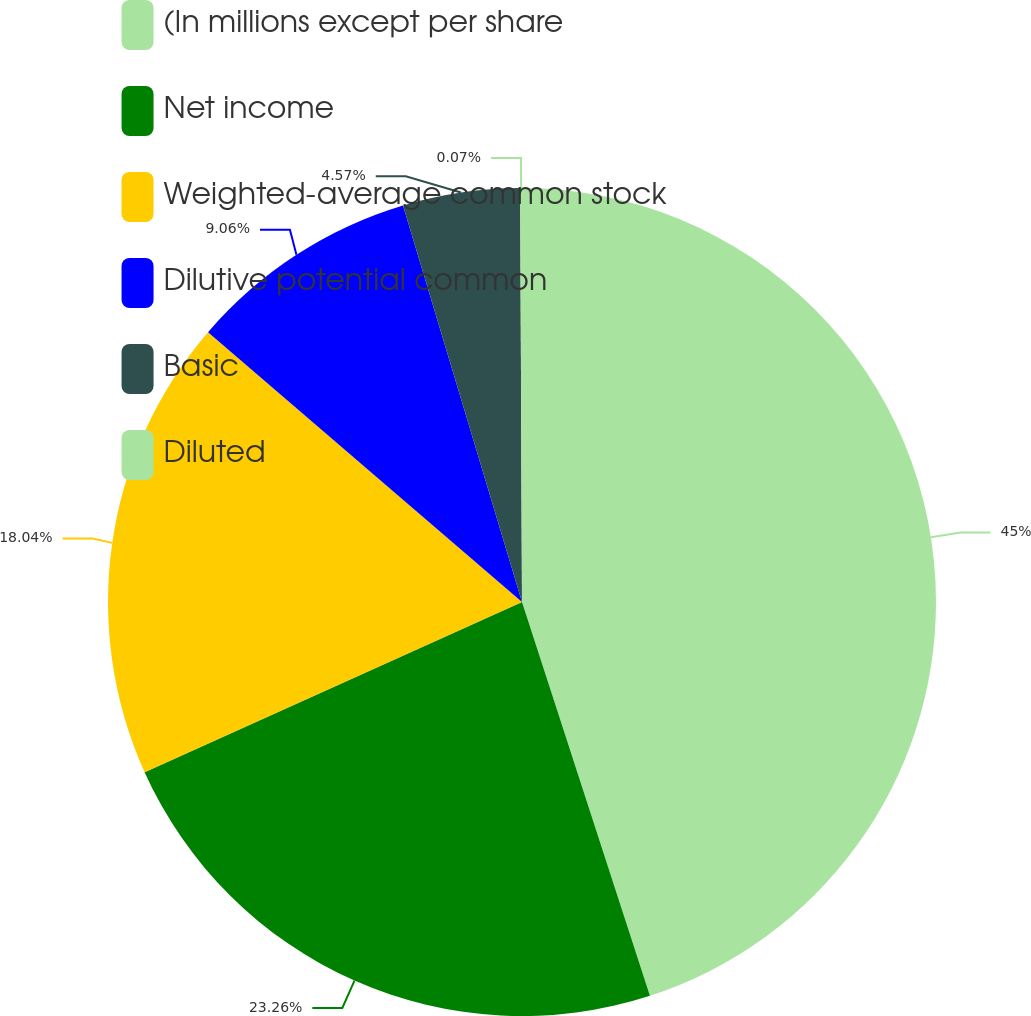Convert chart. <chart><loc_0><loc_0><loc_500><loc_500><pie_chart><fcel>(In millions except per share<fcel>Net income<fcel>Weighted-average common stock<fcel>Dilutive potential common<fcel>Basic<fcel>Diluted<nl><fcel>45.0%<fcel>23.26%<fcel>18.04%<fcel>9.06%<fcel>4.57%<fcel>0.07%<nl></chart> 